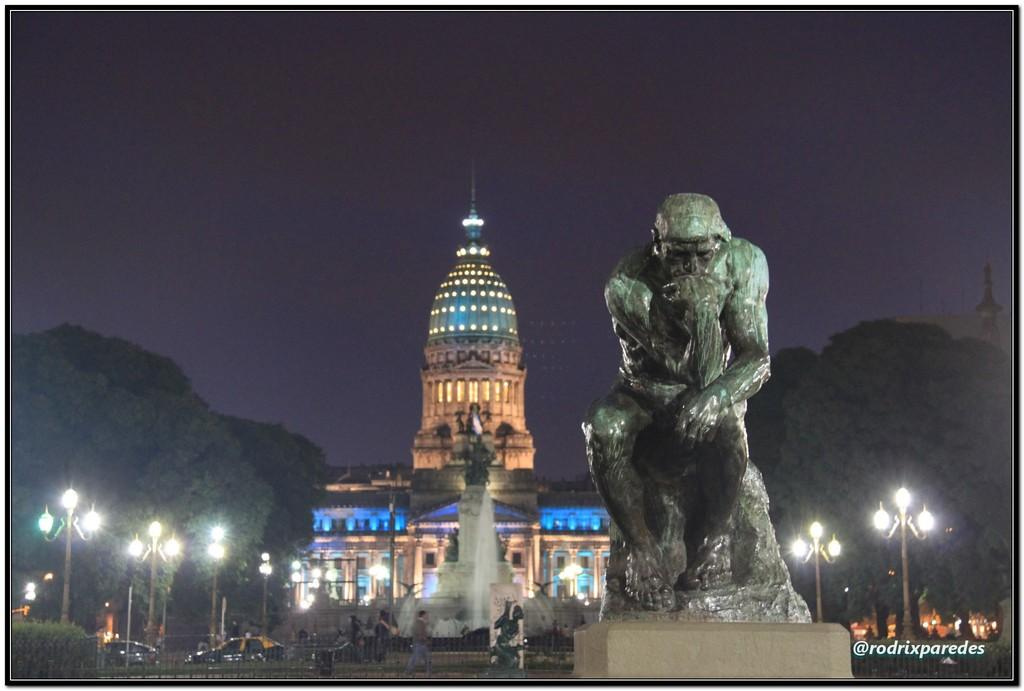What is the main subject of the image? There is a sculpture in the image. What can be seen in the background of the image? There is a water fountain, trees, poles, lights, vehicles, and a building in the background of the image. What color is the polish on the sculpture's eyes in the image? There are no eyes or polish mentioned in the image, as it features a sculpture and various background elements. 